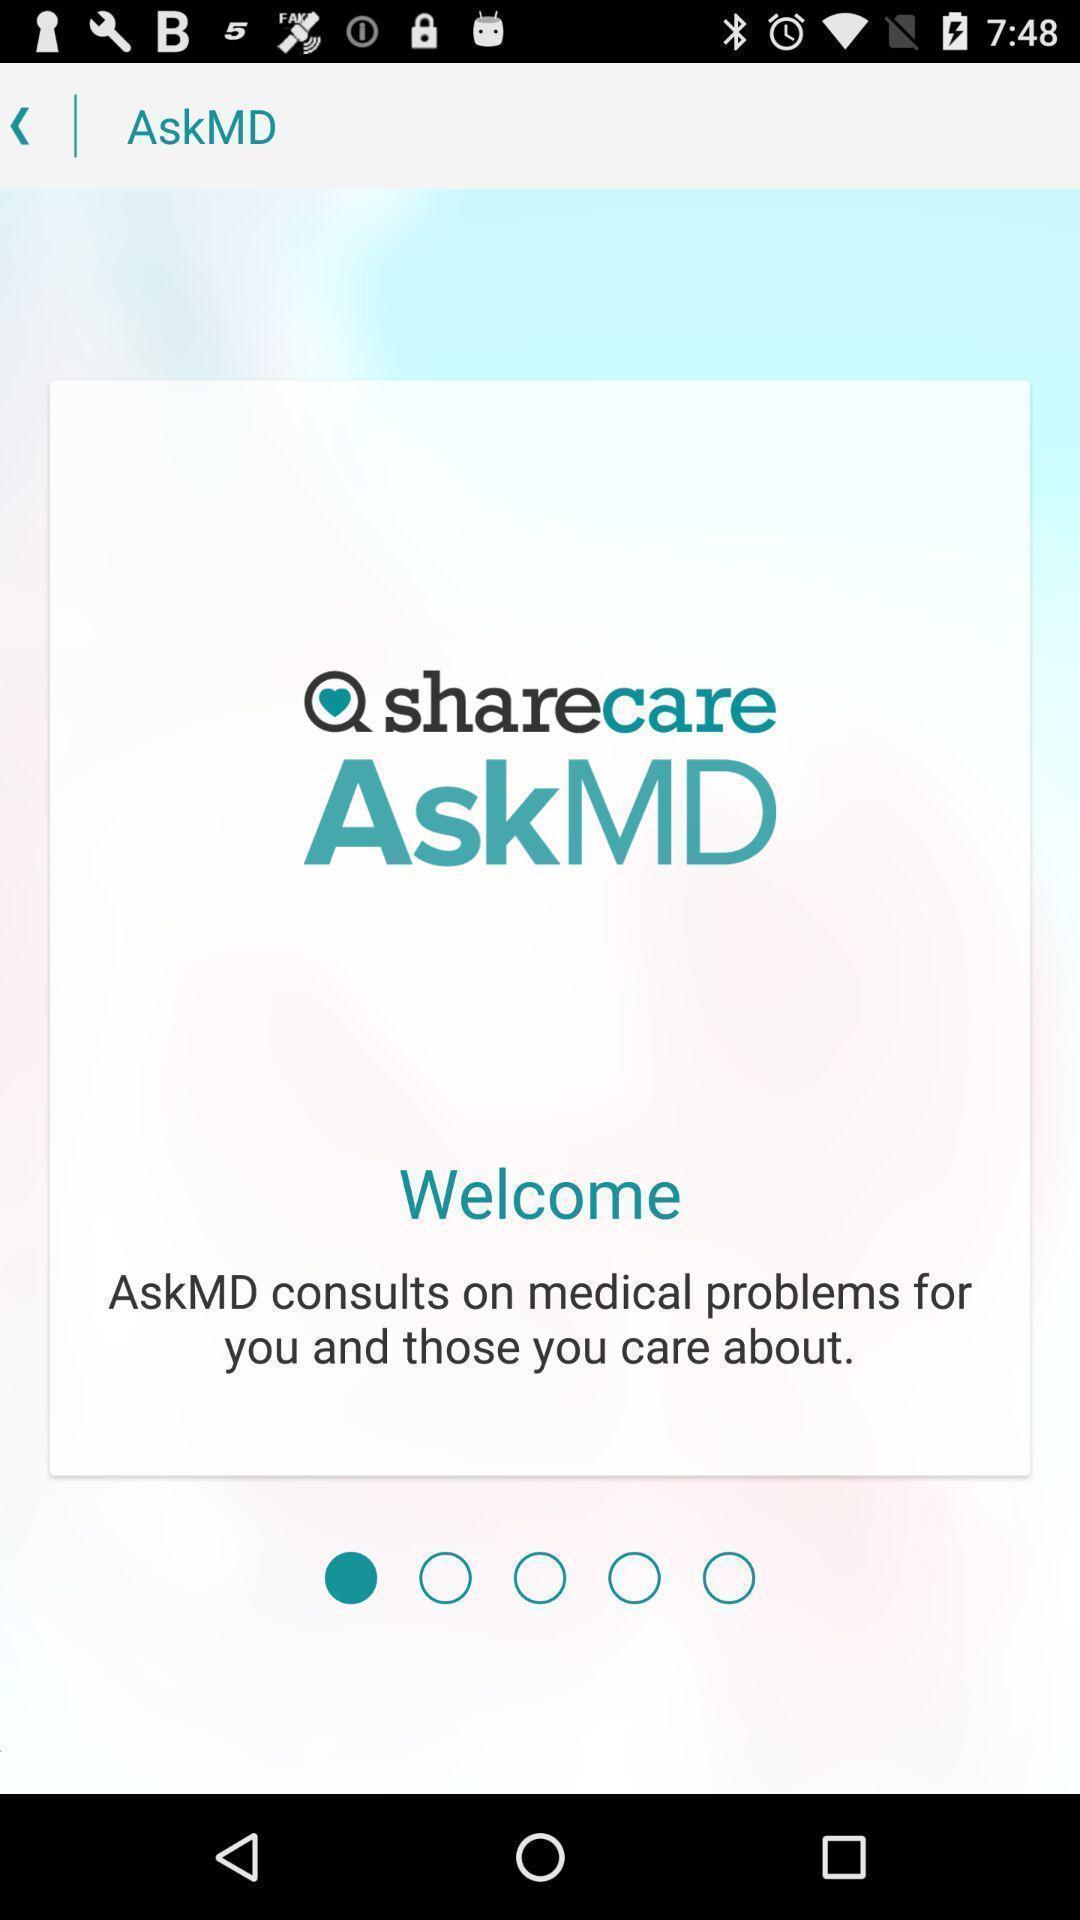Describe the key features of this screenshot. Welcome page of the medical aide application. 